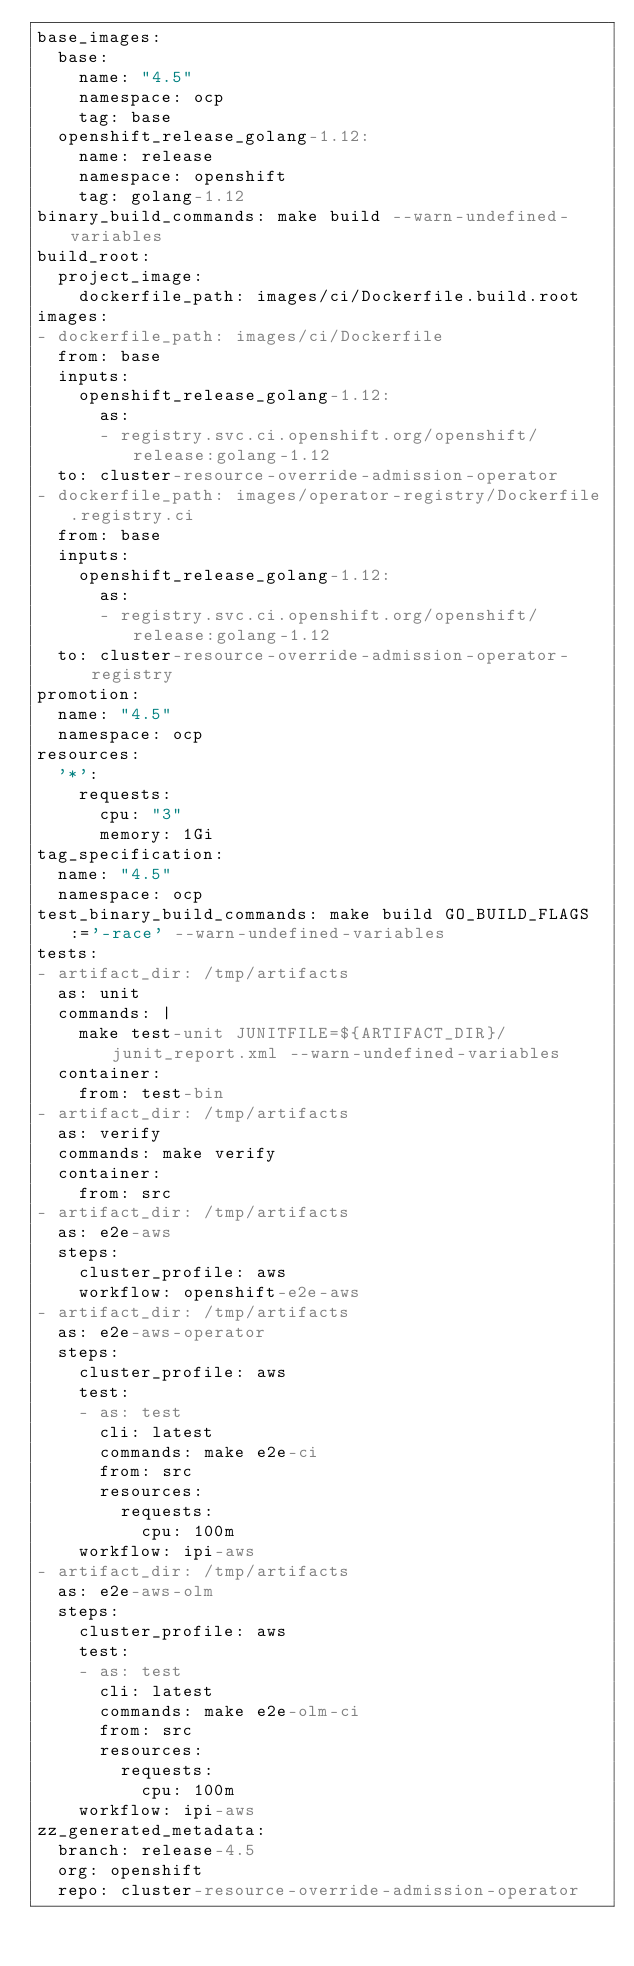Convert code to text. <code><loc_0><loc_0><loc_500><loc_500><_YAML_>base_images:
  base:
    name: "4.5"
    namespace: ocp
    tag: base
  openshift_release_golang-1.12:
    name: release
    namespace: openshift
    tag: golang-1.12
binary_build_commands: make build --warn-undefined-variables
build_root:
  project_image:
    dockerfile_path: images/ci/Dockerfile.build.root
images:
- dockerfile_path: images/ci/Dockerfile
  from: base
  inputs:
    openshift_release_golang-1.12:
      as:
      - registry.svc.ci.openshift.org/openshift/release:golang-1.12
  to: cluster-resource-override-admission-operator
- dockerfile_path: images/operator-registry/Dockerfile.registry.ci
  from: base
  inputs:
    openshift_release_golang-1.12:
      as:
      - registry.svc.ci.openshift.org/openshift/release:golang-1.12
  to: cluster-resource-override-admission-operator-registry
promotion:
  name: "4.5"
  namespace: ocp
resources:
  '*':
    requests:
      cpu: "3"
      memory: 1Gi
tag_specification:
  name: "4.5"
  namespace: ocp
test_binary_build_commands: make build GO_BUILD_FLAGS:='-race' --warn-undefined-variables
tests:
- artifact_dir: /tmp/artifacts
  as: unit
  commands: |
    make test-unit JUNITFILE=${ARTIFACT_DIR}/junit_report.xml --warn-undefined-variables
  container:
    from: test-bin
- artifact_dir: /tmp/artifacts
  as: verify
  commands: make verify
  container:
    from: src
- artifact_dir: /tmp/artifacts
  as: e2e-aws
  steps:
    cluster_profile: aws
    workflow: openshift-e2e-aws
- artifact_dir: /tmp/artifacts
  as: e2e-aws-operator
  steps:
    cluster_profile: aws
    test:
    - as: test
      cli: latest
      commands: make e2e-ci
      from: src
      resources:
        requests:
          cpu: 100m
    workflow: ipi-aws
- artifact_dir: /tmp/artifacts
  as: e2e-aws-olm
  steps:
    cluster_profile: aws
    test:
    - as: test
      cli: latest
      commands: make e2e-olm-ci
      from: src
      resources:
        requests:
          cpu: 100m
    workflow: ipi-aws
zz_generated_metadata:
  branch: release-4.5
  org: openshift
  repo: cluster-resource-override-admission-operator
</code> 